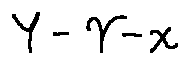<formula> <loc_0><loc_0><loc_500><loc_500>Y - \gamma - x</formula> 